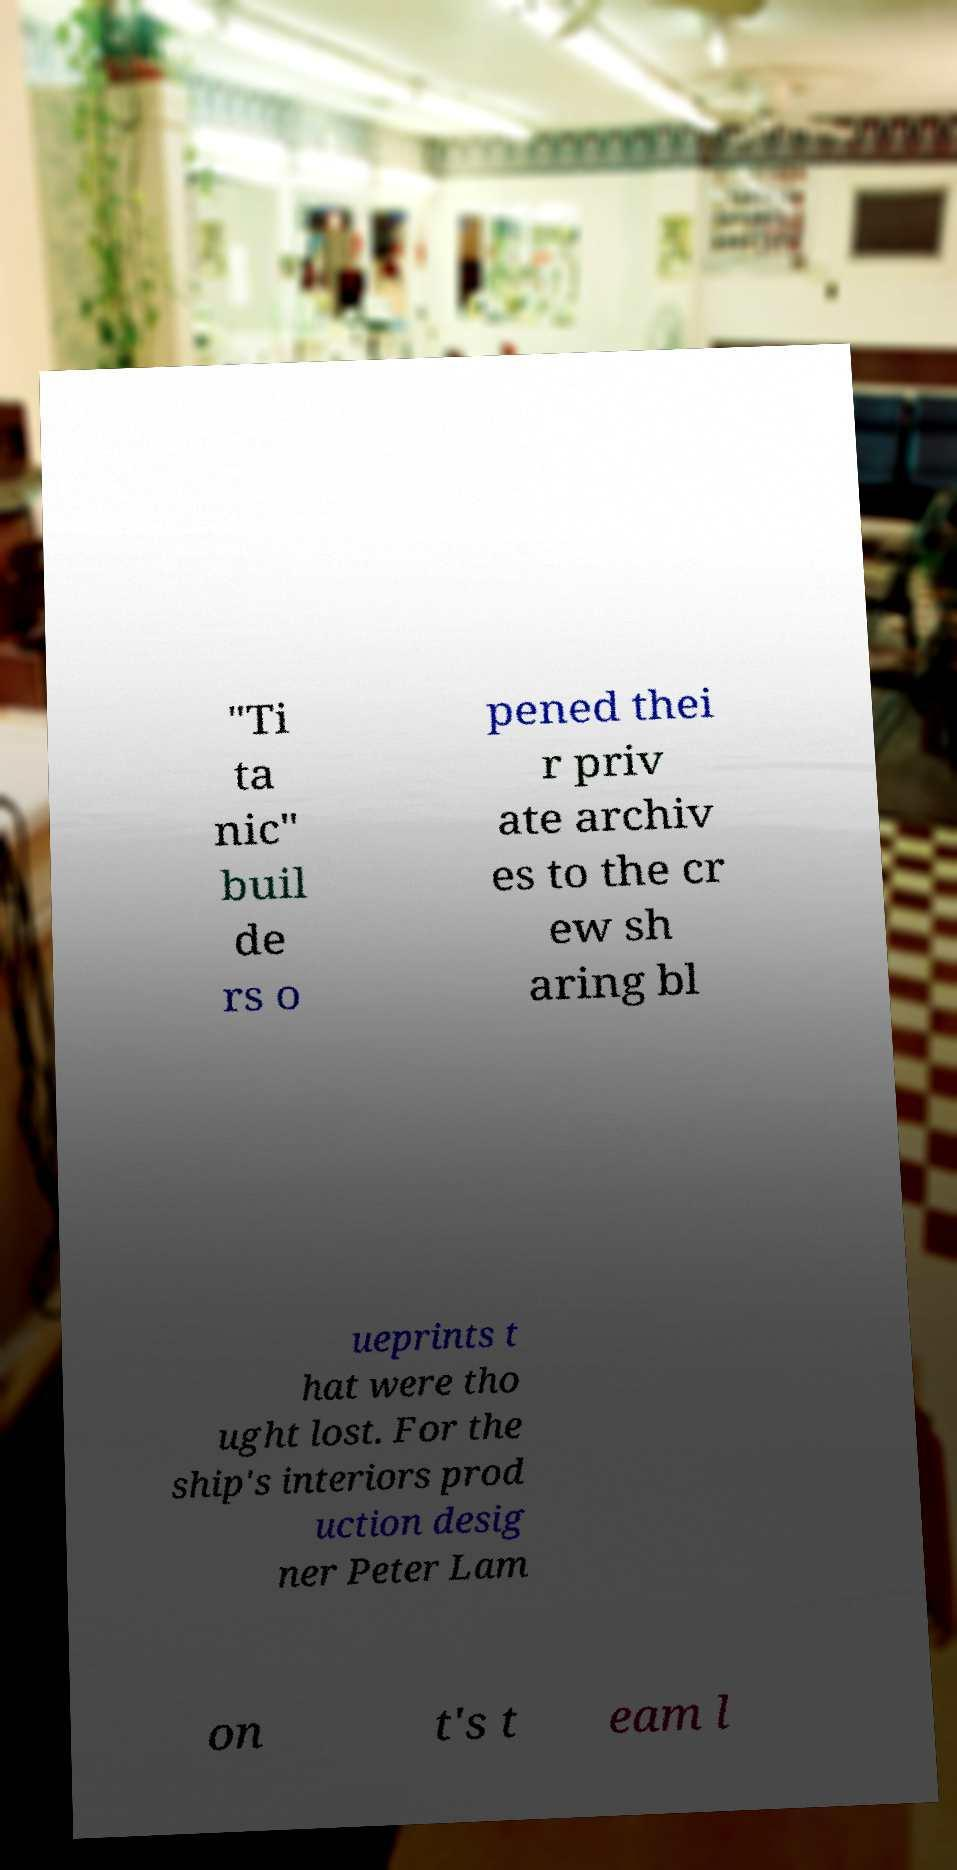Can you accurately transcribe the text from the provided image for me? "Ti ta nic" buil de rs o pened thei r priv ate archiv es to the cr ew sh aring bl ueprints t hat were tho ught lost. For the ship's interiors prod uction desig ner Peter Lam on t's t eam l 